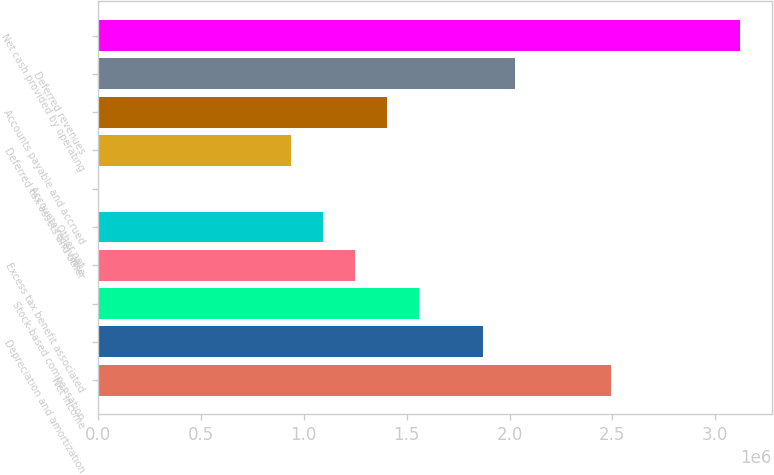Convert chart. <chart><loc_0><loc_0><loc_500><loc_500><bar_chart><fcel>Net income<fcel>Depreciation and amortization<fcel>Stock-based compensation<fcel>Excess tax benefit associated<fcel>Other net<fcel>Accounts receivable<fcel>Deferred tax assets and other<fcel>Accounts payable and accrued<fcel>Deferred revenues<fcel>Net cash provided by operating<nl><fcel>2.49525e+06<fcel>1.8715e+06<fcel>1.55963e+06<fcel>1.24775e+06<fcel>1.09181e+06<fcel>251<fcel>935877<fcel>1.40369e+06<fcel>2.02744e+06<fcel>3.119e+06<nl></chart> 